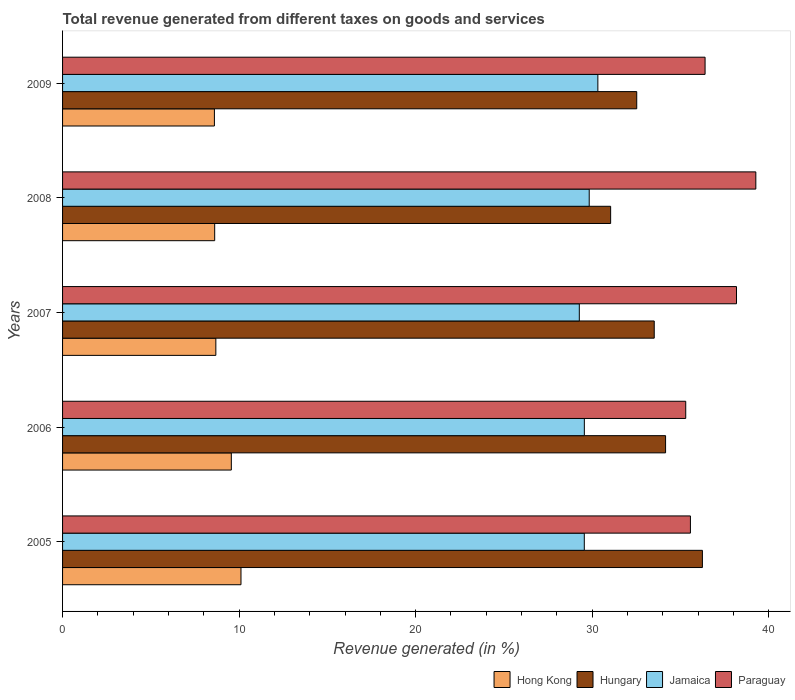In how many cases, is the number of bars for a given year not equal to the number of legend labels?
Your answer should be very brief. 0. What is the total revenue generated in Paraguay in 2009?
Offer a terse response. 36.4. Across all years, what is the maximum total revenue generated in Hong Kong?
Keep it short and to the point. 10.11. Across all years, what is the minimum total revenue generated in Paraguay?
Keep it short and to the point. 35.3. What is the total total revenue generated in Paraguay in the graph?
Your answer should be compact. 184.71. What is the difference between the total revenue generated in Paraguay in 2005 and that in 2008?
Ensure brevity in your answer.  -3.7. What is the difference between the total revenue generated in Paraguay in 2009 and the total revenue generated in Hungary in 2008?
Provide a succinct answer. 5.35. What is the average total revenue generated in Paraguay per year?
Provide a succinct answer. 36.94. In the year 2006, what is the difference between the total revenue generated in Hungary and total revenue generated in Hong Kong?
Provide a short and direct response. 24.6. In how many years, is the total revenue generated in Hungary greater than 24 %?
Provide a short and direct response. 5. What is the ratio of the total revenue generated in Paraguay in 2007 to that in 2009?
Your answer should be very brief. 1.05. What is the difference between the highest and the second highest total revenue generated in Hungary?
Give a very brief answer. 2.09. What is the difference between the highest and the lowest total revenue generated in Jamaica?
Give a very brief answer. 1.05. Is the sum of the total revenue generated in Hungary in 2007 and 2008 greater than the maximum total revenue generated in Paraguay across all years?
Offer a very short reply. Yes. What does the 2nd bar from the top in 2005 represents?
Give a very brief answer. Jamaica. What does the 2nd bar from the bottom in 2008 represents?
Offer a very short reply. Hungary. Is it the case that in every year, the sum of the total revenue generated in Jamaica and total revenue generated in Paraguay is greater than the total revenue generated in Hong Kong?
Keep it short and to the point. Yes. Are all the bars in the graph horizontal?
Ensure brevity in your answer.  Yes. What is the difference between two consecutive major ticks on the X-axis?
Ensure brevity in your answer.  10. How many legend labels are there?
Offer a terse response. 4. How are the legend labels stacked?
Your answer should be compact. Horizontal. What is the title of the graph?
Offer a very short reply. Total revenue generated from different taxes on goods and services. Does "Singapore" appear as one of the legend labels in the graph?
Offer a very short reply. No. What is the label or title of the X-axis?
Your answer should be compact. Revenue generated (in %). What is the label or title of the Y-axis?
Your response must be concise. Years. What is the Revenue generated (in %) of Hong Kong in 2005?
Offer a very short reply. 10.11. What is the Revenue generated (in %) in Hungary in 2005?
Ensure brevity in your answer.  36.24. What is the Revenue generated (in %) of Jamaica in 2005?
Provide a short and direct response. 29.55. What is the Revenue generated (in %) of Paraguay in 2005?
Provide a succinct answer. 35.57. What is the Revenue generated (in %) in Hong Kong in 2006?
Keep it short and to the point. 9.56. What is the Revenue generated (in %) in Hungary in 2006?
Your answer should be very brief. 34.16. What is the Revenue generated (in %) of Jamaica in 2006?
Make the answer very short. 29.56. What is the Revenue generated (in %) of Paraguay in 2006?
Ensure brevity in your answer.  35.3. What is the Revenue generated (in %) in Hong Kong in 2007?
Make the answer very short. 8.68. What is the Revenue generated (in %) of Hungary in 2007?
Provide a succinct answer. 33.52. What is the Revenue generated (in %) in Jamaica in 2007?
Your response must be concise. 29.27. What is the Revenue generated (in %) in Paraguay in 2007?
Give a very brief answer. 38.18. What is the Revenue generated (in %) of Hong Kong in 2008?
Your answer should be compact. 8.62. What is the Revenue generated (in %) in Hungary in 2008?
Provide a short and direct response. 31.05. What is the Revenue generated (in %) in Jamaica in 2008?
Provide a succinct answer. 29.83. What is the Revenue generated (in %) in Paraguay in 2008?
Your response must be concise. 39.27. What is the Revenue generated (in %) of Hong Kong in 2009?
Offer a terse response. 8.6. What is the Revenue generated (in %) of Hungary in 2009?
Make the answer very short. 32.52. What is the Revenue generated (in %) in Jamaica in 2009?
Provide a short and direct response. 30.32. What is the Revenue generated (in %) of Paraguay in 2009?
Ensure brevity in your answer.  36.4. Across all years, what is the maximum Revenue generated (in %) in Hong Kong?
Offer a terse response. 10.11. Across all years, what is the maximum Revenue generated (in %) of Hungary?
Ensure brevity in your answer.  36.24. Across all years, what is the maximum Revenue generated (in %) in Jamaica?
Provide a succinct answer. 30.32. Across all years, what is the maximum Revenue generated (in %) in Paraguay?
Your answer should be compact. 39.27. Across all years, what is the minimum Revenue generated (in %) of Hong Kong?
Offer a terse response. 8.6. Across all years, what is the minimum Revenue generated (in %) in Hungary?
Make the answer very short. 31.05. Across all years, what is the minimum Revenue generated (in %) of Jamaica?
Make the answer very short. 29.27. Across all years, what is the minimum Revenue generated (in %) of Paraguay?
Offer a terse response. 35.3. What is the total Revenue generated (in %) in Hong Kong in the graph?
Keep it short and to the point. 45.57. What is the total Revenue generated (in %) in Hungary in the graph?
Keep it short and to the point. 167.49. What is the total Revenue generated (in %) of Jamaica in the graph?
Make the answer very short. 148.54. What is the total Revenue generated (in %) of Paraguay in the graph?
Provide a succinct answer. 184.71. What is the difference between the Revenue generated (in %) of Hong Kong in 2005 and that in 2006?
Give a very brief answer. 0.55. What is the difference between the Revenue generated (in %) in Hungary in 2005 and that in 2006?
Your answer should be very brief. 2.09. What is the difference between the Revenue generated (in %) of Jamaica in 2005 and that in 2006?
Give a very brief answer. -0. What is the difference between the Revenue generated (in %) in Paraguay in 2005 and that in 2006?
Make the answer very short. 0.27. What is the difference between the Revenue generated (in %) of Hong Kong in 2005 and that in 2007?
Provide a succinct answer. 1.42. What is the difference between the Revenue generated (in %) in Hungary in 2005 and that in 2007?
Provide a succinct answer. 2.73. What is the difference between the Revenue generated (in %) of Jamaica in 2005 and that in 2007?
Offer a terse response. 0.28. What is the difference between the Revenue generated (in %) of Paraguay in 2005 and that in 2007?
Your answer should be compact. -2.61. What is the difference between the Revenue generated (in %) in Hong Kong in 2005 and that in 2008?
Keep it short and to the point. 1.49. What is the difference between the Revenue generated (in %) in Hungary in 2005 and that in 2008?
Your response must be concise. 5.2. What is the difference between the Revenue generated (in %) in Jamaica in 2005 and that in 2008?
Provide a succinct answer. -0.28. What is the difference between the Revenue generated (in %) of Paraguay in 2005 and that in 2008?
Offer a very short reply. -3.7. What is the difference between the Revenue generated (in %) in Hong Kong in 2005 and that in 2009?
Give a very brief answer. 1.51. What is the difference between the Revenue generated (in %) in Hungary in 2005 and that in 2009?
Give a very brief answer. 3.72. What is the difference between the Revenue generated (in %) in Jamaica in 2005 and that in 2009?
Offer a terse response. -0.77. What is the difference between the Revenue generated (in %) of Paraguay in 2005 and that in 2009?
Provide a succinct answer. -0.83. What is the difference between the Revenue generated (in %) in Hong Kong in 2006 and that in 2007?
Provide a succinct answer. 0.88. What is the difference between the Revenue generated (in %) in Hungary in 2006 and that in 2007?
Your answer should be very brief. 0.64. What is the difference between the Revenue generated (in %) in Jamaica in 2006 and that in 2007?
Your response must be concise. 0.28. What is the difference between the Revenue generated (in %) of Paraguay in 2006 and that in 2007?
Offer a terse response. -2.88. What is the difference between the Revenue generated (in %) in Hong Kong in 2006 and that in 2008?
Provide a short and direct response. 0.94. What is the difference between the Revenue generated (in %) in Hungary in 2006 and that in 2008?
Give a very brief answer. 3.11. What is the difference between the Revenue generated (in %) of Jamaica in 2006 and that in 2008?
Your answer should be compact. -0.28. What is the difference between the Revenue generated (in %) of Paraguay in 2006 and that in 2008?
Offer a terse response. -3.97. What is the difference between the Revenue generated (in %) in Hong Kong in 2006 and that in 2009?
Give a very brief answer. 0.96. What is the difference between the Revenue generated (in %) in Hungary in 2006 and that in 2009?
Make the answer very short. 1.63. What is the difference between the Revenue generated (in %) in Jamaica in 2006 and that in 2009?
Ensure brevity in your answer.  -0.77. What is the difference between the Revenue generated (in %) of Paraguay in 2006 and that in 2009?
Offer a very short reply. -1.1. What is the difference between the Revenue generated (in %) in Hong Kong in 2007 and that in 2008?
Your answer should be very brief. 0.07. What is the difference between the Revenue generated (in %) of Hungary in 2007 and that in 2008?
Ensure brevity in your answer.  2.47. What is the difference between the Revenue generated (in %) of Jamaica in 2007 and that in 2008?
Your answer should be very brief. -0.56. What is the difference between the Revenue generated (in %) of Paraguay in 2007 and that in 2008?
Keep it short and to the point. -1.09. What is the difference between the Revenue generated (in %) in Hong Kong in 2007 and that in 2009?
Give a very brief answer. 0.08. What is the difference between the Revenue generated (in %) of Jamaica in 2007 and that in 2009?
Your answer should be very brief. -1.05. What is the difference between the Revenue generated (in %) in Paraguay in 2007 and that in 2009?
Your answer should be compact. 1.78. What is the difference between the Revenue generated (in %) of Hong Kong in 2008 and that in 2009?
Your response must be concise. 0.02. What is the difference between the Revenue generated (in %) of Hungary in 2008 and that in 2009?
Ensure brevity in your answer.  -1.48. What is the difference between the Revenue generated (in %) in Jamaica in 2008 and that in 2009?
Provide a short and direct response. -0.49. What is the difference between the Revenue generated (in %) of Paraguay in 2008 and that in 2009?
Offer a terse response. 2.87. What is the difference between the Revenue generated (in %) in Hong Kong in 2005 and the Revenue generated (in %) in Hungary in 2006?
Make the answer very short. -24.05. What is the difference between the Revenue generated (in %) of Hong Kong in 2005 and the Revenue generated (in %) of Jamaica in 2006?
Make the answer very short. -19.45. What is the difference between the Revenue generated (in %) in Hong Kong in 2005 and the Revenue generated (in %) in Paraguay in 2006?
Offer a terse response. -25.19. What is the difference between the Revenue generated (in %) in Hungary in 2005 and the Revenue generated (in %) in Jamaica in 2006?
Give a very brief answer. 6.69. What is the difference between the Revenue generated (in %) of Hungary in 2005 and the Revenue generated (in %) of Paraguay in 2006?
Offer a very short reply. 0.94. What is the difference between the Revenue generated (in %) in Jamaica in 2005 and the Revenue generated (in %) in Paraguay in 2006?
Ensure brevity in your answer.  -5.75. What is the difference between the Revenue generated (in %) of Hong Kong in 2005 and the Revenue generated (in %) of Hungary in 2007?
Your response must be concise. -23.41. What is the difference between the Revenue generated (in %) in Hong Kong in 2005 and the Revenue generated (in %) in Jamaica in 2007?
Ensure brevity in your answer.  -19.17. What is the difference between the Revenue generated (in %) of Hong Kong in 2005 and the Revenue generated (in %) of Paraguay in 2007?
Give a very brief answer. -28.07. What is the difference between the Revenue generated (in %) of Hungary in 2005 and the Revenue generated (in %) of Jamaica in 2007?
Keep it short and to the point. 6.97. What is the difference between the Revenue generated (in %) in Hungary in 2005 and the Revenue generated (in %) in Paraguay in 2007?
Offer a terse response. -1.93. What is the difference between the Revenue generated (in %) of Jamaica in 2005 and the Revenue generated (in %) of Paraguay in 2007?
Give a very brief answer. -8.62. What is the difference between the Revenue generated (in %) of Hong Kong in 2005 and the Revenue generated (in %) of Hungary in 2008?
Offer a terse response. -20.94. What is the difference between the Revenue generated (in %) of Hong Kong in 2005 and the Revenue generated (in %) of Jamaica in 2008?
Make the answer very short. -19.73. What is the difference between the Revenue generated (in %) of Hong Kong in 2005 and the Revenue generated (in %) of Paraguay in 2008?
Give a very brief answer. -29.16. What is the difference between the Revenue generated (in %) in Hungary in 2005 and the Revenue generated (in %) in Jamaica in 2008?
Keep it short and to the point. 6.41. What is the difference between the Revenue generated (in %) in Hungary in 2005 and the Revenue generated (in %) in Paraguay in 2008?
Offer a terse response. -3.03. What is the difference between the Revenue generated (in %) in Jamaica in 2005 and the Revenue generated (in %) in Paraguay in 2008?
Your answer should be compact. -9.72. What is the difference between the Revenue generated (in %) in Hong Kong in 2005 and the Revenue generated (in %) in Hungary in 2009?
Give a very brief answer. -22.42. What is the difference between the Revenue generated (in %) of Hong Kong in 2005 and the Revenue generated (in %) of Jamaica in 2009?
Make the answer very short. -20.22. What is the difference between the Revenue generated (in %) in Hong Kong in 2005 and the Revenue generated (in %) in Paraguay in 2009?
Ensure brevity in your answer.  -26.29. What is the difference between the Revenue generated (in %) of Hungary in 2005 and the Revenue generated (in %) of Jamaica in 2009?
Make the answer very short. 5.92. What is the difference between the Revenue generated (in %) in Hungary in 2005 and the Revenue generated (in %) in Paraguay in 2009?
Ensure brevity in your answer.  -0.15. What is the difference between the Revenue generated (in %) in Jamaica in 2005 and the Revenue generated (in %) in Paraguay in 2009?
Your answer should be very brief. -6.84. What is the difference between the Revenue generated (in %) of Hong Kong in 2006 and the Revenue generated (in %) of Hungary in 2007?
Your response must be concise. -23.96. What is the difference between the Revenue generated (in %) in Hong Kong in 2006 and the Revenue generated (in %) in Jamaica in 2007?
Make the answer very short. -19.71. What is the difference between the Revenue generated (in %) in Hong Kong in 2006 and the Revenue generated (in %) in Paraguay in 2007?
Give a very brief answer. -28.62. What is the difference between the Revenue generated (in %) of Hungary in 2006 and the Revenue generated (in %) of Jamaica in 2007?
Give a very brief answer. 4.89. What is the difference between the Revenue generated (in %) of Hungary in 2006 and the Revenue generated (in %) of Paraguay in 2007?
Your answer should be compact. -4.02. What is the difference between the Revenue generated (in %) of Jamaica in 2006 and the Revenue generated (in %) of Paraguay in 2007?
Ensure brevity in your answer.  -8.62. What is the difference between the Revenue generated (in %) of Hong Kong in 2006 and the Revenue generated (in %) of Hungary in 2008?
Your answer should be very brief. -21.49. What is the difference between the Revenue generated (in %) of Hong Kong in 2006 and the Revenue generated (in %) of Jamaica in 2008?
Keep it short and to the point. -20.27. What is the difference between the Revenue generated (in %) in Hong Kong in 2006 and the Revenue generated (in %) in Paraguay in 2008?
Make the answer very short. -29.71. What is the difference between the Revenue generated (in %) in Hungary in 2006 and the Revenue generated (in %) in Jamaica in 2008?
Your response must be concise. 4.33. What is the difference between the Revenue generated (in %) in Hungary in 2006 and the Revenue generated (in %) in Paraguay in 2008?
Provide a short and direct response. -5.11. What is the difference between the Revenue generated (in %) of Jamaica in 2006 and the Revenue generated (in %) of Paraguay in 2008?
Ensure brevity in your answer.  -9.71. What is the difference between the Revenue generated (in %) of Hong Kong in 2006 and the Revenue generated (in %) of Hungary in 2009?
Provide a short and direct response. -22.96. What is the difference between the Revenue generated (in %) of Hong Kong in 2006 and the Revenue generated (in %) of Jamaica in 2009?
Your answer should be compact. -20.76. What is the difference between the Revenue generated (in %) in Hong Kong in 2006 and the Revenue generated (in %) in Paraguay in 2009?
Offer a terse response. -26.84. What is the difference between the Revenue generated (in %) of Hungary in 2006 and the Revenue generated (in %) of Jamaica in 2009?
Give a very brief answer. 3.84. What is the difference between the Revenue generated (in %) of Hungary in 2006 and the Revenue generated (in %) of Paraguay in 2009?
Offer a very short reply. -2.24. What is the difference between the Revenue generated (in %) in Jamaica in 2006 and the Revenue generated (in %) in Paraguay in 2009?
Give a very brief answer. -6.84. What is the difference between the Revenue generated (in %) in Hong Kong in 2007 and the Revenue generated (in %) in Hungary in 2008?
Give a very brief answer. -22.36. What is the difference between the Revenue generated (in %) of Hong Kong in 2007 and the Revenue generated (in %) of Jamaica in 2008?
Offer a terse response. -21.15. What is the difference between the Revenue generated (in %) in Hong Kong in 2007 and the Revenue generated (in %) in Paraguay in 2008?
Provide a short and direct response. -30.59. What is the difference between the Revenue generated (in %) of Hungary in 2007 and the Revenue generated (in %) of Jamaica in 2008?
Make the answer very short. 3.68. What is the difference between the Revenue generated (in %) in Hungary in 2007 and the Revenue generated (in %) in Paraguay in 2008?
Your response must be concise. -5.76. What is the difference between the Revenue generated (in %) in Jamaica in 2007 and the Revenue generated (in %) in Paraguay in 2008?
Your answer should be very brief. -10. What is the difference between the Revenue generated (in %) of Hong Kong in 2007 and the Revenue generated (in %) of Hungary in 2009?
Offer a terse response. -23.84. What is the difference between the Revenue generated (in %) of Hong Kong in 2007 and the Revenue generated (in %) of Jamaica in 2009?
Your answer should be very brief. -21.64. What is the difference between the Revenue generated (in %) of Hong Kong in 2007 and the Revenue generated (in %) of Paraguay in 2009?
Make the answer very short. -27.71. What is the difference between the Revenue generated (in %) in Hungary in 2007 and the Revenue generated (in %) in Jamaica in 2009?
Make the answer very short. 3.19. What is the difference between the Revenue generated (in %) in Hungary in 2007 and the Revenue generated (in %) in Paraguay in 2009?
Provide a short and direct response. -2.88. What is the difference between the Revenue generated (in %) in Jamaica in 2007 and the Revenue generated (in %) in Paraguay in 2009?
Ensure brevity in your answer.  -7.12. What is the difference between the Revenue generated (in %) in Hong Kong in 2008 and the Revenue generated (in %) in Hungary in 2009?
Provide a succinct answer. -23.91. What is the difference between the Revenue generated (in %) of Hong Kong in 2008 and the Revenue generated (in %) of Jamaica in 2009?
Offer a very short reply. -21.71. What is the difference between the Revenue generated (in %) in Hong Kong in 2008 and the Revenue generated (in %) in Paraguay in 2009?
Give a very brief answer. -27.78. What is the difference between the Revenue generated (in %) in Hungary in 2008 and the Revenue generated (in %) in Jamaica in 2009?
Provide a short and direct response. 0.72. What is the difference between the Revenue generated (in %) in Hungary in 2008 and the Revenue generated (in %) in Paraguay in 2009?
Provide a short and direct response. -5.35. What is the difference between the Revenue generated (in %) in Jamaica in 2008 and the Revenue generated (in %) in Paraguay in 2009?
Your response must be concise. -6.56. What is the average Revenue generated (in %) of Hong Kong per year?
Keep it short and to the point. 9.11. What is the average Revenue generated (in %) of Hungary per year?
Your answer should be very brief. 33.5. What is the average Revenue generated (in %) in Jamaica per year?
Provide a succinct answer. 29.71. What is the average Revenue generated (in %) of Paraguay per year?
Give a very brief answer. 36.94. In the year 2005, what is the difference between the Revenue generated (in %) of Hong Kong and Revenue generated (in %) of Hungary?
Your answer should be very brief. -26.14. In the year 2005, what is the difference between the Revenue generated (in %) of Hong Kong and Revenue generated (in %) of Jamaica?
Provide a succinct answer. -19.45. In the year 2005, what is the difference between the Revenue generated (in %) of Hong Kong and Revenue generated (in %) of Paraguay?
Your answer should be compact. -25.46. In the year 2005, what is the difference between the Revenue generated (in %) of Hungary and Revenue generated (in %) of Jamaica?
Give a very brief answer. 6.69. In the year 2005, what is the difference between the Revenue generated (in %) in Hungary and Revenue generated (in %) in Paraguay?
Provide a succinct answer. 0.68. In the year 2005, what is the difference between the Revenue generated (in %) of Jamaica and Revenue generated (in %) of Paraguay?
Offer a terse response. -6.01. In the year 2006, what is the difference between the Revenue generated (in %) in Hong Kong and Revenue generated (in %) in Hungary?
Your answer should be compact. -24.6. In the year 2006, what is the difference between the Revenue generated (in %) in Hong Kong and Revenue generated (in %) in Jamaica?
Your answer should be compact. -20. In the year 2006, what is the difference between the Revenue generated (in %) of Hong Kong and Revenue generated (in %) of Paraguay?
Provide a short and direct response. -25.74. In the year 2006, what is the difference between the Revenue generated (in %) in Hungary and Revenue generated (in %) in Jamaica?
Ensure brevity in your answer.  4.6. In the year 2006, what is the difference between the Revenue generated (in %) of Hungary and Revenue generated (in %) of Paraguay?
Your response must be concise. -1.14. In the year 2006, what is the difference between the Revenue generated (in %) in Jamaica and Revenue generated (in %) in Paraguay?
Your answer should be very brief. -5.74. In the year 2007, what is the difference between the Revenue generated (in %) in Hong Kong and Revenue generated (in %) in Hungary?
Your response must be concise. -24.83. In the year 2007, what is the difference between the Revenue generated (in %) in Hong Kong and Revenue generated (in %) in Jamaica?
Your answer should be compact. -20.59. In the year 2007, what is the difference between the Revenue generated (in %) in Hong Kong and Revenue generated (in %) in Paraguay?
Your response must be concise. -29.49. In the year 2007, what is the difference between the Revenue generated (in %) in Hungary and Revenue generated (in %) in Jamaica?
Offer a terse response. 4.24. In the year 2007, what is the difference between the Revenue generated (in %) in Hungary and Revenue generated (in %) in Paraguay?
Your response must be concise. -4.66. In the year 2007, what is the difference between the Revenue generated (in %) of Jamaica and Revenue generated (in %) of Paraguay?
Offer a terse response. -8.9. In the year 2008, what is the difference between the Revenue generated (in %) in Hong Kong and Revenue generated (in %) in Hungary?
Your response must be concise. -22.43. In the year 2008, what is the difference between the Revenue generated (in %) of Hong Kong and Revenue generated (in %) of Jamaica?
Your answer should be compact. -21.22. In the year 2008, what is the difference between the Revenue generated (in %) in Hong Kong and Revenue generated (in %) in Paraguay?
Provide a succinct answer. -30.65. In the year 2008, what is the difference between the Revenue generated (in %) of Hungary and Revenue generated (in %) of Jamaica?
Ensure brevity in your answer.  1.21. In the year 2008, what is the difference between the Revenue generated (in %) in Hungary and Revenue generated (in %) in Paraguay?
Give a very brief answer. -8.22. In the year 2008, what is the difference between the Revenue generated (in %) of Jamaica and Revenue generated (in %) of Paraguay?
Make the answer very short. -9.44. In the year 2009, what is the difference between the Revenue generated (in %) in Hong Kong and Revenue generated (in %) in Hungary?
Provide a succinct answer. -23.92. In the year 2009, what is the difference between the Revenue generated (in %) in Hong Kong and Revenue generated (in %) in Jamaica?
Offer a terse response. -21.72. In the year 2009, what is the difference between the Revenue generated (in %) in Hong Kong and Revenue generated (in %) in Paraguay?
Give a very brief answer. -27.8. In the year 2009, what is the difference between the Revenue generated (in %) of Hungary and Revenue generated (in %) of Jamaica?
Your answer should be compact. 2.2. In the year 2009, what is the difference between the Revenue generated (in %) of Hungary and Revenue generated (in %) of Paraguay?
Provide a succinct answer. -3.87. In the year 2009, what is the difference between the Revenue generated (in %) in Jamaica and Revenue generated (in %) in Paraguay?
Provide a short and direct response. -6.07. What is the ratio of the Revenue generated (in %) of Hong Kong in 2005 to that in 2006?
Offer a terse response. 1.06. What is the ratio of the Revenue generated (in %) in Hungary in 2005 to that in 2006?
Your answer should be very brief. 1.06. What is the ratio of the Revenue generated (in %) in Paraguay in 2005 to that in 2006?
Provide a succinct answer. 1.01. What is the ratio of the Revenue generated (in %) of Hong Kong in 2005 to that in 2007?
Your answer should be very brief. 1.16. What is the ratio of the Revenue generated (in %) of Hungary in 2005 to that in 2007?
Your answer should be very brief. 1.08. What is the ratio of the Revenue generated (in %) of Jamaica in 2005 to that in 2007?
Make the answer very short. 1.01. What is the ratio of the Revenue generated (in %) of Paraguay in 2005 to that in 2007?
Your answer should be very brief. 0.93. What is the ratio of the Revenue generated (in %) of Hong Kong in 2005 to that in 2008?
Your answer should be compact. 1.17. What is the ratio of the Revenue generated (in %) of Hungary in 2005 to that in 2008?
Give a very brief answer. 1.17. What is the ratio of the Revenue generated (in %) in Paraguay in 2005 to that in 2008?
Make the answer very short. 0.91. What is the ratio of the Revenue generated (in %) in Hong Kong in 2005 to that in 2009?
Keep it short and to the point. 1.18. What is the ratio of the Revenue generated (in %) in Hungary in 2005 to that in 2009?
Your answer should be very brief. 1.11. What is the ratio of the Revenue generated (in %) of Jamaica in 2005 to that in 2009?
Provide a short and direct response. 0.97. What is the ratio of the Revenue generated (in %) in Paraguay in 2005 to that in 2009?
Offer a very short reply. 0.98. What is the ratio of the Revenue generated (in %) of Hong Kong in 2006 to that in 2007?
Offer a terse response. 1.1. What is the ratio of the Revenue generated (in %) of Hungary in 2006 to that in 2007?
Your answer should be very brief. 1.02. What is the ratio of the Revenue generated (in %) of Jamaica in 2006 to that in 2007?
Make the answer very short. 1.01. What is the ratio of the Revenue generated (in %) in Paraguay in 2006 to that in 2007?
Offer a terse response. 0.92. What is the ratio of the Revenue generated (in %) in Hong Kong in 2006 to that in 2008?
Your answer should be very brief. 1.11. What is the ratio of the Revenue generated (in %) in Hungary in 2006 to that in 2008?
Make the answer very short. 1.1. What is the ratio of the Revenue generated (in %) of Jamaica in 2006 to that in 2008?
Your answer should be very brief. 0.99. What is the ratio of the Revenue generated (in %) in Paraguay in 2006 to that in 2008?
Your answer should be compact. 0.9. What is the ratio of the Revenue generated (in %) in Hong Kong in 2006 to that in 2009?
Your response must be concise. 1.11. What is the ratio of the Revenue generated (in %) in Hungary in 2006 to that in 2009?
Give a very brief answer. 1.05. What is the ratio of the Revenue generated (in %) of Jamaica in 2006 to that in 2009?
Your answer should be very brief. 0.97. What is the ratio of the Revenue generated (in %) in Paraguay in 2006 to that in 2009?
Give a very brief answer. 0.97. What is the ratio of the Revenue generated (in %) of Hong Kong in 2007 to that in 2008?
Give a very brief answer. 1.01. What is the ratio of the Revenue generated (in %) of Hungary in 2007 to that in 2008?
Your answer should be very brief. 1.08. What is the ratio of the Revenue generated (in %) of Jamaica in 2007 to that in 2008?
Ensure brevity in your answer.  0.98. What is the ratio of the Revenue generated (in %) in Paraguay in 2007 to that in 2008?
Offer a terse response. 0.97. What is the ratio of the Revenue generated (in %) in Hong Kong in 2007 to that in 2009?
Your answer should be compact. 1.01. What is the ratio of the Revenue generated (in %) in Hungary in 2007 to that in 2009?
Provide a succinct answer. 1.03. What is the ratio of the Revenue generated (in %) in Jamaica in 2007 to that in 2009?
Provide a succinct answer. 0.97. What is the ratio of the Revenue generated (in %) in Paraguay in 2007 to that in 2009?
Provide a succinct answer. 1.05. What is the ratio of the Revenue generated (in %) of Hong Kong in 2008 to that in 2009?
Offer a very short reply. 1. What is the ratio of the Revenue generated (in %) in Hungary in 2008 to that in 2009?
Your response must be concise. 0.95. What is the ratio of the Revenue generated (in %) in Jamaica in 2008 to that in 2009?
Your response must be concise. 0.98. What is the ratio of the Revenue generated (in %) of Paraguay in 2008 to that in 2009?
Make the answer very short. 1.08. What is the difference between the highest and the second highest Revenue generated (in %) in Hong Kong?
Provide a short and direct response. 0.55. What is the difference between the highest and the second highest Revenue generated (in %) in Hungary?
Provide a succinct answer. 2.09. What is the difference between the highest and the second highest Revenue generated (in %) of Jamaica?
Provide a succinct answer. 0.49. What is the difference between the highest and the second highest Revenue generated (in %) of Paraguay?
Your answer should be very brief. 1.09. What is the difference between the highest and the lowest Revenue generated (in %) of Hong Kong?
Your answer should be compact. 1.51. What is the difference between the highest and the lowest Revenue generated (in %) in Hungary?
Provide a short and direct response. 5.2. What is the difference between the highest and the lowest Revenue generated (in %) in Jamaica?
Your response must be concise. 1.05. What is the difference between the highest and the lowest Revenue generated (in %) in Paraguay?
Your answer should be very brief. 3.97. 